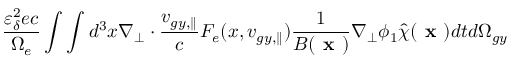Convert formula to latex. <formula><loc_0><loc_0><loc_500><loc_500>\frac { \varepsilon _ { \delta } ^ { 2 } e c } { \Omega _ { e } } \int \int d ^ { 3 } x \nabla _ { \perp } \cdot \frac { v _ { g y , \| } } { c } F _ { e } ( x , v _ { g y , \| } ) \frac { 1 } { B ( x ) } \nabla _ { \perp } \phi _ { 1 } \hat { \chi } ( x ) d t d \Omega _ { g y }</formula> 